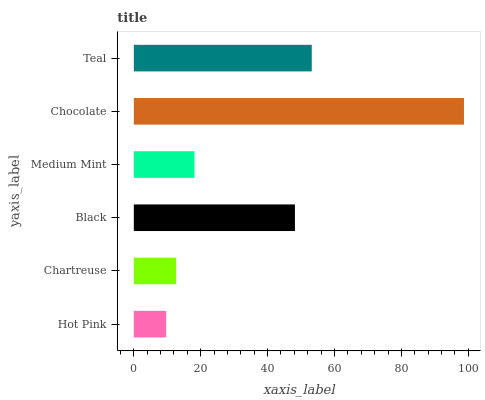Is Hot Pink the minimum?
Answer yes or no. Yes. Is Chocolate the maximum?
Answer yes or no. Yes. Is Chartreuse the minimum?
Answer yes or no. No. Is Chartreuse the maximum?
Answer yes or no. No. Is Chartreuse greater than Hot Pink?
Answer yes or no. Yes. Is Hot Pink less than Chartreuse?
Answer yes or no. Yes. Is Hot Pink greater than Chartreuse?
Answer yes or no. No. Is Chartreuse less than Hot Pink?
Answer yes or no. No. Is Black the high median?
Answer yes or no. Yes. Is Medium Mint the low median?
Answer yes or no. Yes. Is Chocolate the high median?
Answer yes or no. No. Is Hot Pink the low median?
Answer yes or no. No. 